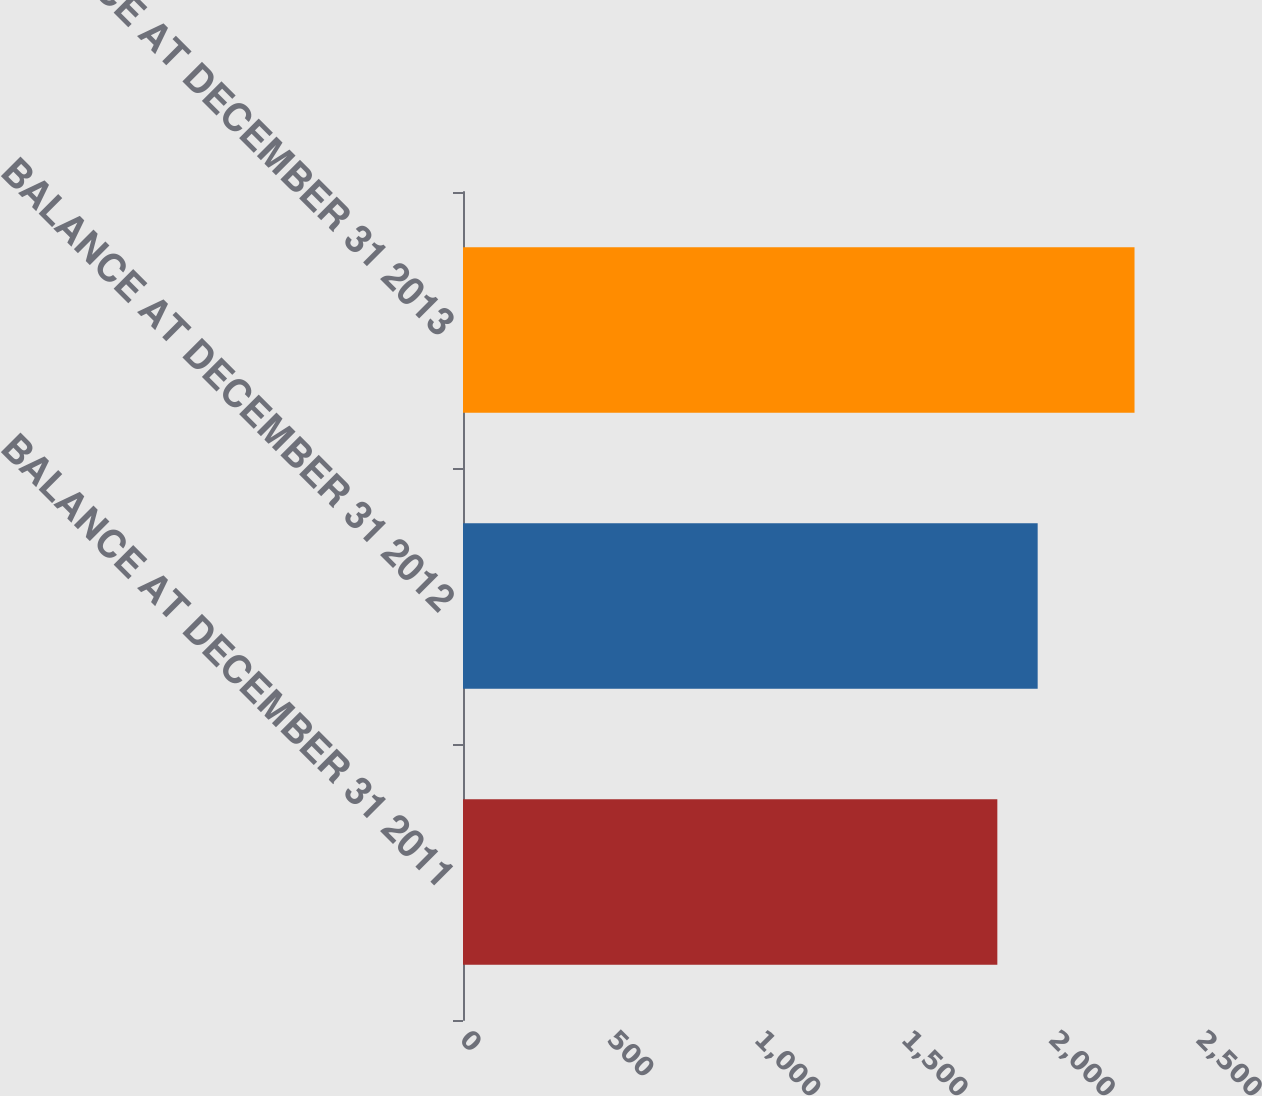Convert chart to OTSL. <chart><loc_0><loc_0><loc_500><loc_500><bar_chart><fcel>BALANCE AT DECEMBER 31 2011<fcel>BALANCE AT DECEMBER 31 2012<fcel>BALANCE AT DECEMBER 31 2013<nl><fcel>1815<fcel>1952<fcel>2281<nl></chart> 